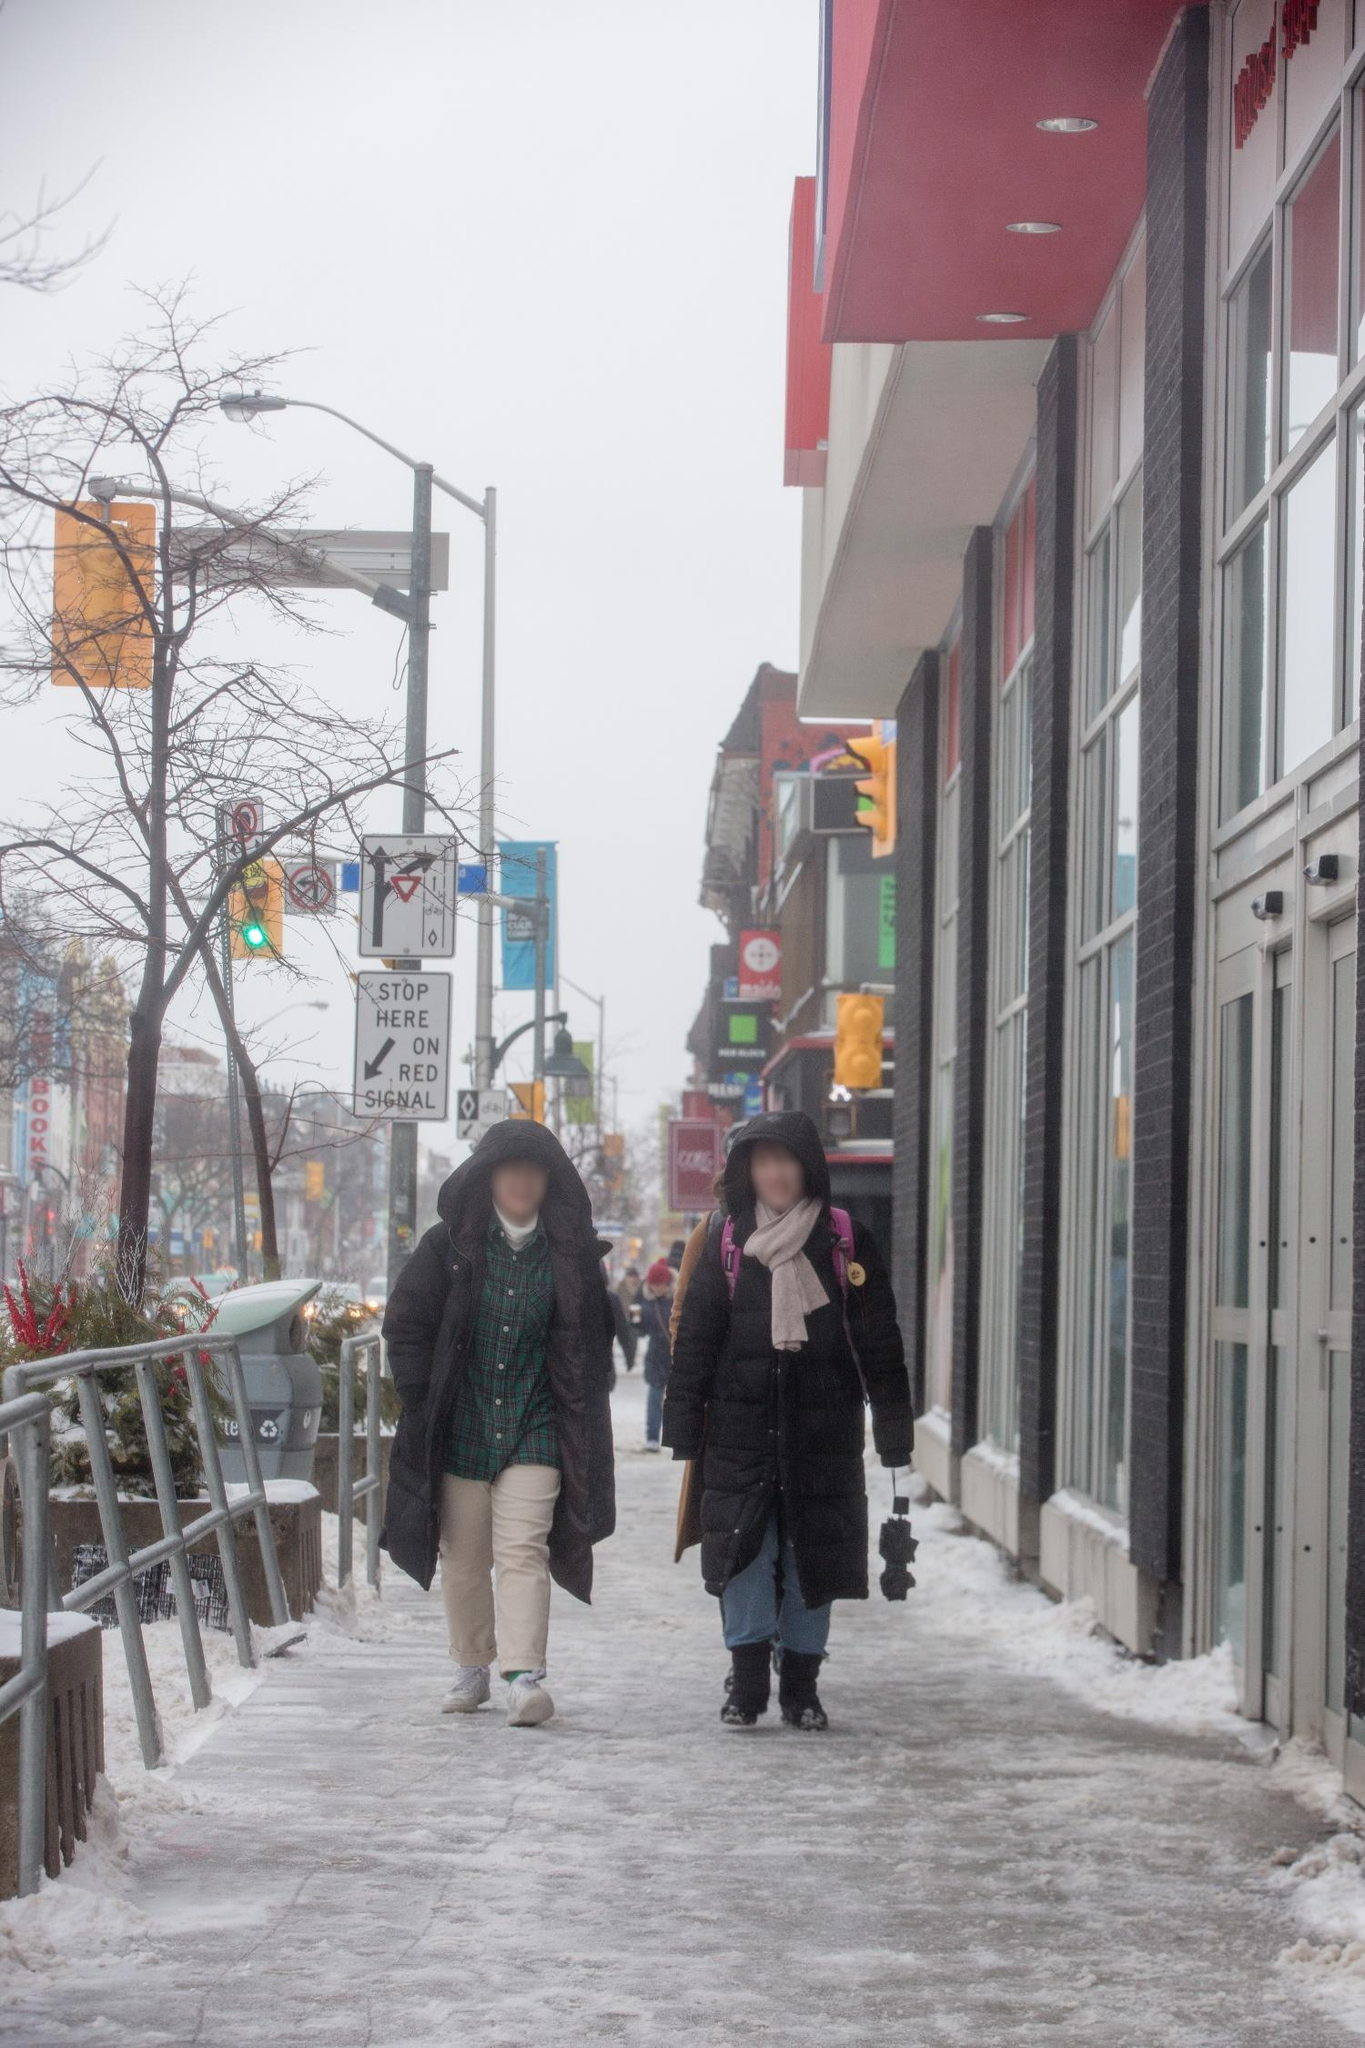Tell me something surprising about the city scene in this image. One surprising element of this city scene is how the snow, usually an indicator of inactivity, actually highlights a subtly vibrant, ongoing urban life. Despite the cold, we see a red building that adds warmth and character, reminiscent of the city's unyielding spirit. The traffic lights and street signs hint at a mild but constant flow of city life, with people going about their daily routines unfazed by the weather. Additionally, the plants along the railing stubbornly retain green despite the snow, symbolizing resilience and continuity. If this scene were part of a movie, what genre would it belong to? This scene would fit beautifully into a romantic comedy or a heartfelt drama. The quiet charm of the snow-covered street and the soft interaction between the two individuals could be a pivotal moment of reconnection, new beginnings, or even a heartfelt goodbye. It could also serve as the backdrop for an unexpected twist or a heartwarming reunion, with the city's vibrant undercurrent subtly supporting the storyline. 